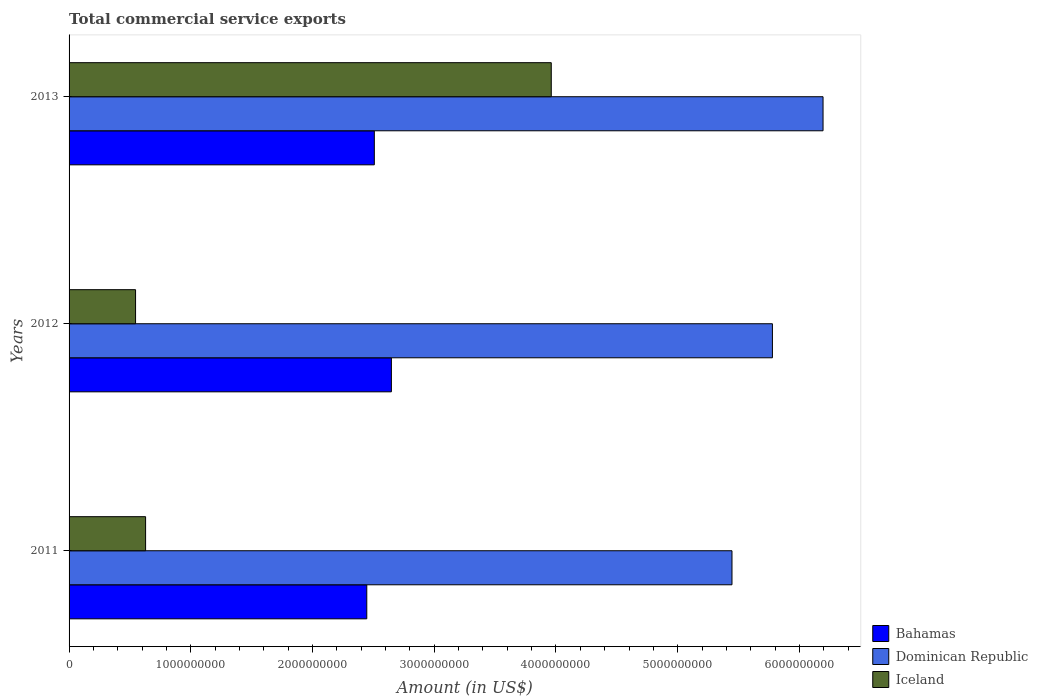How many different coloured bars are there?
Your answer should be very brief. 3. Are the number of bars on each tick of the Y-axis equal?
Your answer should be very brief. Yes. What is the total commercial service exports in Iceland in 2011?
Your response must be concise. 6.29e+08. Across all years, what is the maximum total commercial service exports in Dominican Republic?
Make the answer very short. 6.19e+09. Across all years, what is the minimum total commercial service exports in Bahamas?
Give a very brief answer. 2.45e+09. In which year was the total commercial service exports in Dominican Republic maximum?
Make the answer very short. 2013. What is the total total commercial service exports in Bahamas in the graph?
Keep it short and to the point. 7.60e+09. What is the difference between the total commercial service exports in Bahamas in 2011 and that in 2013?
Make the answer very short. -6.20e+07. What is the difference between the total commercial service exports in Bahamas in 2011 and the total commercial service exports in Iceland in 2013?
Make the answer very short. -1.52e+09. What is the average total commercial service exports in Iceland per year?
Your answer should be very brief. 1.71e+09. In the year 2011, what is the difference between the total commercial service exports in Dominican Republic and total commercial service exports in Bahamas?
Offer a very short reply. 3.00e+09. In how many years, is the total commercial service exports in Bahamas greater than 1200000000 US$?
Keep it short and to the point. 3. What is the ratio of the total commercial service exports in Dominican Republic in 2011 to that in 2013?
Your response must be concise. 0.88. Is the difference between the total commercial service exports in Dominican Republic in 2011 and 2013 greater than the difference between the total commercial service exports in Bahamas in 2011 and 2013?
Provide a succinct answer. No. What is the difference between the highest and the second highest total commercial service exports in Iceland?
Provide a short and direct response. 3.33e+09. What is the difference between the highest and the lowest total commercial service exports in Bahamas?
Make the answer very short. 2.02e+08. In how many years, is the total commercial service exports in Dominican Republic greater than the average total commercial service exports in Dominican Republic taken over all years?
Your answer should be compact. 1. What does the 3rd bar from the top in 2011 represents?
Make the answer very short. Bahamas. What does the 1st bar from the bottom in 2011 represents?
Ensure brevity in your answer.  Bahamas. How many bars are there?
Ensure brevity in your answer.  9. Are all the bars in the graph horizontal?
Provide a short and direct response. Yes. How many years are there in the graph?
Ensure brevity in your answer.  3. What is the difference between two consecutive major ticks on the X-axis?
Provide a short and direct response. 1.00e+09. Does the graph contain any zero values?
Your answer should be compact. No. How are the legend labels stacked?
Ensure brevity in your answer.  Vertical. What is the title of the graph?
Make the answer very short. Total commercial service exports. Does "Korea (Democratic)" appear as one of the legend labels in the graph?
Your answer should be very brief. No. What is the label or title of the X-axis?
Offer a very short reply. Amount (in US$). What is the Amount (in US$) of Bahamas in 2011?
Provide a succinct answer. 2.45e+09. What is the Amount (in US$) in Dominican Republic in 2011?
Your answer should be compact. 5.45e+09. What is the Amount (in US$) of Iceland in 2011?
Ensure brevity in your answer.  6.29e+08. What is the Amount (in US$) in Bahamas in 2012?
Offer a very short reply. 2.65e+09. What is the Amount (in US$) of Dominican Republic in 2012?
Provide a succinct answer. 5.78e+09. What is the Amount (in US$) of Iceland in 2012?
Offer a very short reply. 5.46e+08. What is the Amount (in US$) in Bahamas in 2013?
Give a very brief answer. 2.51e+09. What is the Amount (in US$) of Dominican Republic in 2013?
Offer a very short reply. 6.19e+09. What is the Amount (in US$) in Iceland in 2013?
Keep it short and to the point. 3.96e+09. Across all years, what is the maximum Amount (in US$) of Bahamas?
Keep it short and to the point. 2.65e+09. Across all years, what is the maximum Amount (in US$) in Dominican Republic?
Offer a terse response. 6.19e+09. Across all years, what is the maximum Amount (in US$) of Iceland?
Provide a succinct answer. 3.96e+09. Across all years, what is the minimum Amount (in US$) in Bahamas?
Offer a very short reply. 2.45e+09. Across all years, what is the minimum Amount (in US$) in Dominican Republic?
Keep it short and to the point. 5.45e+09. Across all years, what is the minimum Amount (in US$) in Iceland?
Keep it short and to the point. 5.46e+08. What is the total Amount (in US$) in Bahamas in the graph?
Provide a succinct answer. 7.60e+09. What is the total Amount (in US$) in Dominican Republic in the graph?
Ensure brevity in your answer.  1.74e+1. What is the total Amount (in US$) of Iceland in the graph?
Your answer should be compact. 5.14e+09. What is the difference between the Amount (in US$) in Bahamas in 2011 and that in 2012?
Offer a terse response. -2.02e+08. What is the difference between the Amount (in US$) in Dominican Republic in 2011 and that in 2012?
Provide a succinct answer. -3.32e+08. What is the difference between the Amount (in US$) of Iceland in 2011 and that in 2012?
Ensure brevity in your answer.  8.24e+07. What is the difference between the Amount (in US$) in Bahamas in 2011 and that in 2013?
Ensure brevity in your answer.  -6.20e+07. What is the difference between the Amount (in US$) in Dominican Republic in 2011 and that in 2013?
Provide a succinct answer. -7.48e+08. What is the difference between the Amount (in US$) of Iceland in 2011 and that in 2013?
Provide a succinct answer. -3.33e+09. What is the difference between the Amount (in US$) in Bahamas in 2012 and that in 2013?
Your answer should be compact. 1.40e+08. What is the difference between the Amount (in US$) in Dominican Republic in 2012 and that in 2013?
Your response must be concise. -4.16e+08. What is the difference between the Amount (in US$) of Iceland in 2012 and that in 2013?
Offer a terse response. -3.42e+09. What is the difference between the Amount (in US$) in Bahamas in 2011 and the Amount (in US$) in Dominican Republic in 2012?
Provide a short and direct response. -3.33e+09. What is the difference between the Amount (in US$) of Bahamas in 2011 and the Amount (in US$) of Iceland in 2012?
Provide a short and direct response. 1.90e+09. What is the difference between the Amount (in US$) in Dominican Republic in 2011 and the Amount (in US$) in Iceland in 2012?
Keep it short and to the point. 4.90e+09. What is the difference between the Amount (in US$) in Bahamas in 2011 and the Amount (in US$) in Dominican Republic in 2013?
Your answer should be compact. -3.75e+09. What is the difference between the Amount (in US$) in Bahamas in 2011 and the Amount (in US$) in Iceland in 2013?
Your answer should be very brief. -1.52e+09. What is the difference between the Amount (in US$) in Dominican Republic in 2011 and the Amount (in US$) in Iceland in 2013?
Ensure brevity in your answer.  1.48e+09. What is the difference between the Amount (in US$) of Bahamas in 2012 and the Amount (in US$) of Dominican Republic in 2013?
Offer a very short reply. -3.55e+09. What is the difference between the Amount (in US$) in Bahamas in 2012 and the Amount (in US$) in Iceland in 2013?
Offer a terse response. -1.31e+09. What is the difference between the Amount (in US$) of Dominican Republic in 2012 and the Amount (in US$) of Iceland in 2013?
Ensure brevity in your answer.  1.82e+09. What is the average Amount (in US$) in Bahamas per year?
Your response must be concise. 2.53e+09. What is the average Amount (in US$) of Dominican Republic per year?
Make the answer very short. 5.81e+09. What is the average Amount (in US$) in Iceland per year?
Your answer should be compact. 1.71e+09. In the year 2011, what is the difference between the Amount (in US$) of Bahamas and Amount (in US$) of Dominican Republic?
Keep it short and to the point. -3.00e+09. In the year 2011, what is the difference between the Amount (in US$) in Bahamas and Amount (in US$) in Iceland?
Give a very brief answer. 1.82e+09. In the year 2011, what is the difference between the Amount (in US$) of Dominican Republic and Amount (in US$) of Iceland?
Your answer should be very brief. 4.82e+09. In the year 2012, what is the difference between the Amount (in US$) in Bahamas and Amount (in US$) in Dominican Republic?
Offer a terse response. -3.13e+09. In the year 2012, what is the difference between the Amount (in US$) in Bahamas and Amount (in US$) in Iceland?
Provide a short and direct response. 2.10e+09. In the year 2012, what is the difference between the Amount (in US$) in Dominican Republic and Amount (in US$) in Iceland?
Provide a succinct answer. 5.23e+09. In the year 2013, what is the difference between the Amount (in US$) in Bahamas and Amount (in US$) in Dominican Republic?
Give a very brief answer. -3.69e+09. In the year 2013, what is the difference between the Amount (in US$) in Bahamas and Amount (in US$) in Iceland?
Make the answer very short. -1.45e+09. In the year 2013, what is the difference between the Amount (in US$) in Dominican Republic and Amount (in US$) in Iceland?
Your answer should be compact. 2.23e+09. What is the ratio of the Amount (in US$) in Bahamas in 2011 to that in 2012?
Provide a succinct answer. 0.92. What is the ratio of the Amount (in US$) of Dominican Republic in 2011 to that in 2012?
Your answer should be very brief. 0.94. What is the ratio of the Amount (in US$) in Iceland in 2011 to that in 2012?
Your answer should be compact. 1.15. What is the ratio of the Amount (in US$) in Bahamas in 2011 to that in 2013?
Provide a short and direct response. 0.98. What is the ratio of the Amount (in US$) in Dominican Republic in 2011 to that in 2013?
Offer a terse response. 0.88. What is the ratio of the Amount (in US$) of Iceland in 2011 to that in 2013?
Offer a terse response. 0.16. What is the ratio of the Amount (in US$) of Bahamas in 2012 to that in 2013?
Your answer should be compact. 1.06. What is the ratio of the Amount (in US$) in Dominican Republic in 2012 to that in 2013?
Offer a terse response. 0.93. What is the ratio of the Amount (in US$) in Iceland in 2012 to that in 2013?
Offer a terse response. 0.14. What is the difference between the highest and the second highest Amount (in US$) in Bahamas?
Make the answer very short. 1.40e+08. What is the difference between the highest and the second highest Amount (in US$) of Dominican Republic?
Your answer should be compact. 4.16e+08. What is the difference between the highest and the second highest Amount (in US$) of Iceland?
Your response must be concise. 3.33e+09. What is the difference between the highest and the lowest Amount (in US$) of Bahamas?
Make the answer very short. 2.02e+08. What is the difference between the highest and the lowest Amount (in US$) in Dominican Republic?
Provide a short and direct response. 7.48e+08. What is the difference between the highest and the lowest Amount (in US$) of Iceland?
Provide a short and direct response. 3.42e+09. 